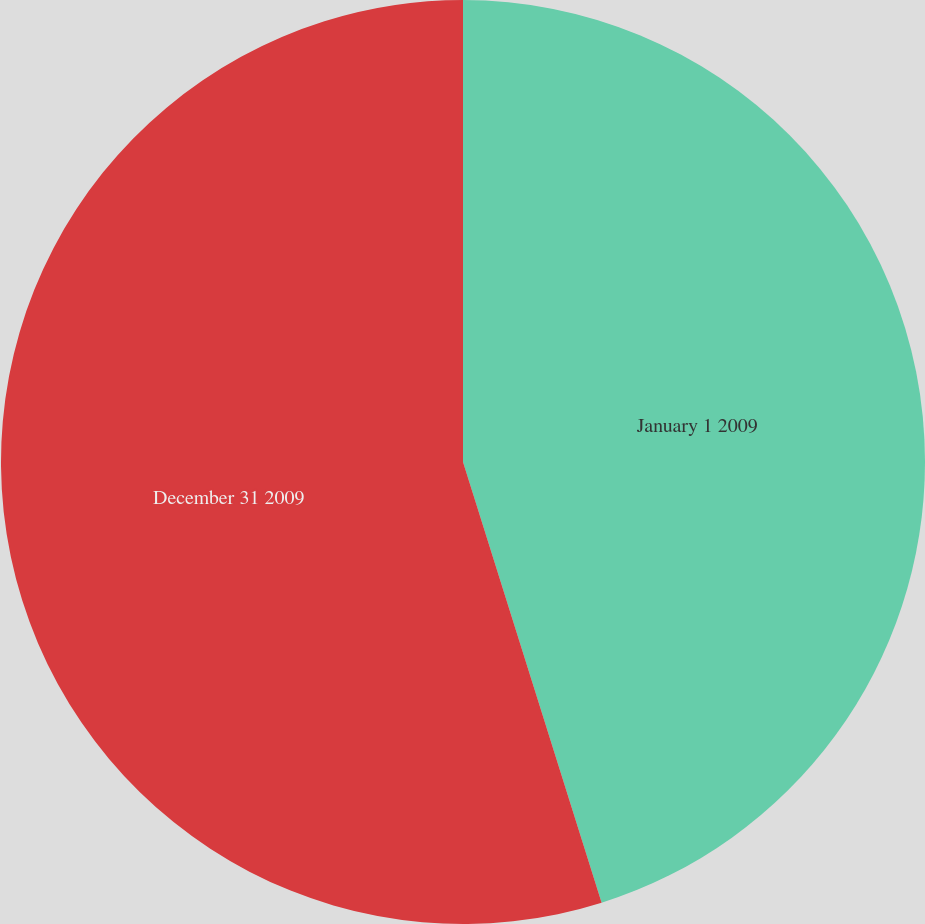Convert chart. <chart><loc_0><loc_0><loc_500><loc_500><pie_chart><fcel>January 1 2009<fcel>December 31 2009<nl><fcel>45.15%<fcel>54.85%<nl></chart> 